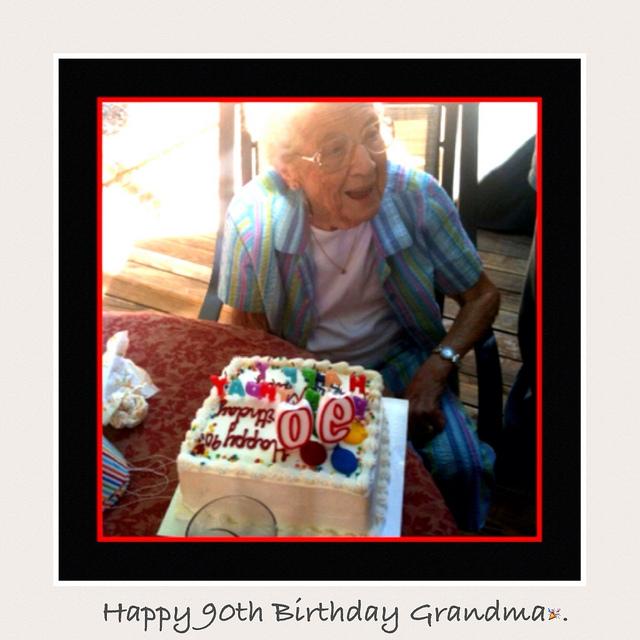Is the cake decorated?
Answer briefly. Yes. At what facility is this taking place?
Concise answer only. Home. How old is the person?
Concise answer only. 90. Whose birthday is it?
Short answer required. Grandma. What color is the man's shirt?
Quick response, please. White. 